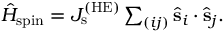<formula> <loc_0><loc_0><loc_500><loc_500>\begin{array} { r } { \hat { H } _ { s p i n } = J _ { s } ^ { ( H E ) } \sum _ { ( i j ) } \hat { s } _ { i } \cdot \hat { s } _ { j } . } \end{array}</formula> 